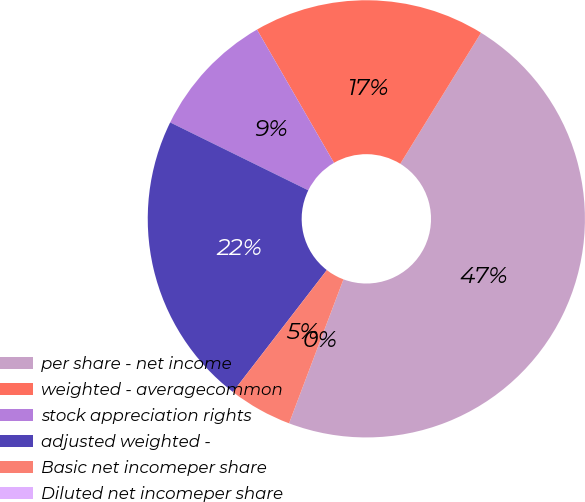<chart> <loc_0><loc_0><loc_500><loc_500><pie_chart><fcel>per share - net income<fcel>weighted - averagecommon<fcel>stock appreciation rights<fcel>adjusted weighted -<fcel>Basic net incomeper share<fcel>Diluted net incomeper share<nl><fcel>46.96%<fcel>17.13%<fcel>9.39%<fcel>21.82%<fcel>4.7%<fcel>0.0%<nl></chart> 